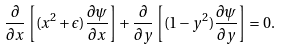Convert formula to latex. <formula><loc_0><loc_0><loc_500><loc_500>\frac { \partial } { \partial x } \left [ ( x ^ { 2 } + \epsilon ) \frac { \partial \psi } { \partial x } \right ] + \frac { \partial } { \partial y } \left [ ( 1 - y ^ { 2 } ) \frac { \partial \psi } { \partial y } \right ] = 0 .</formula> 